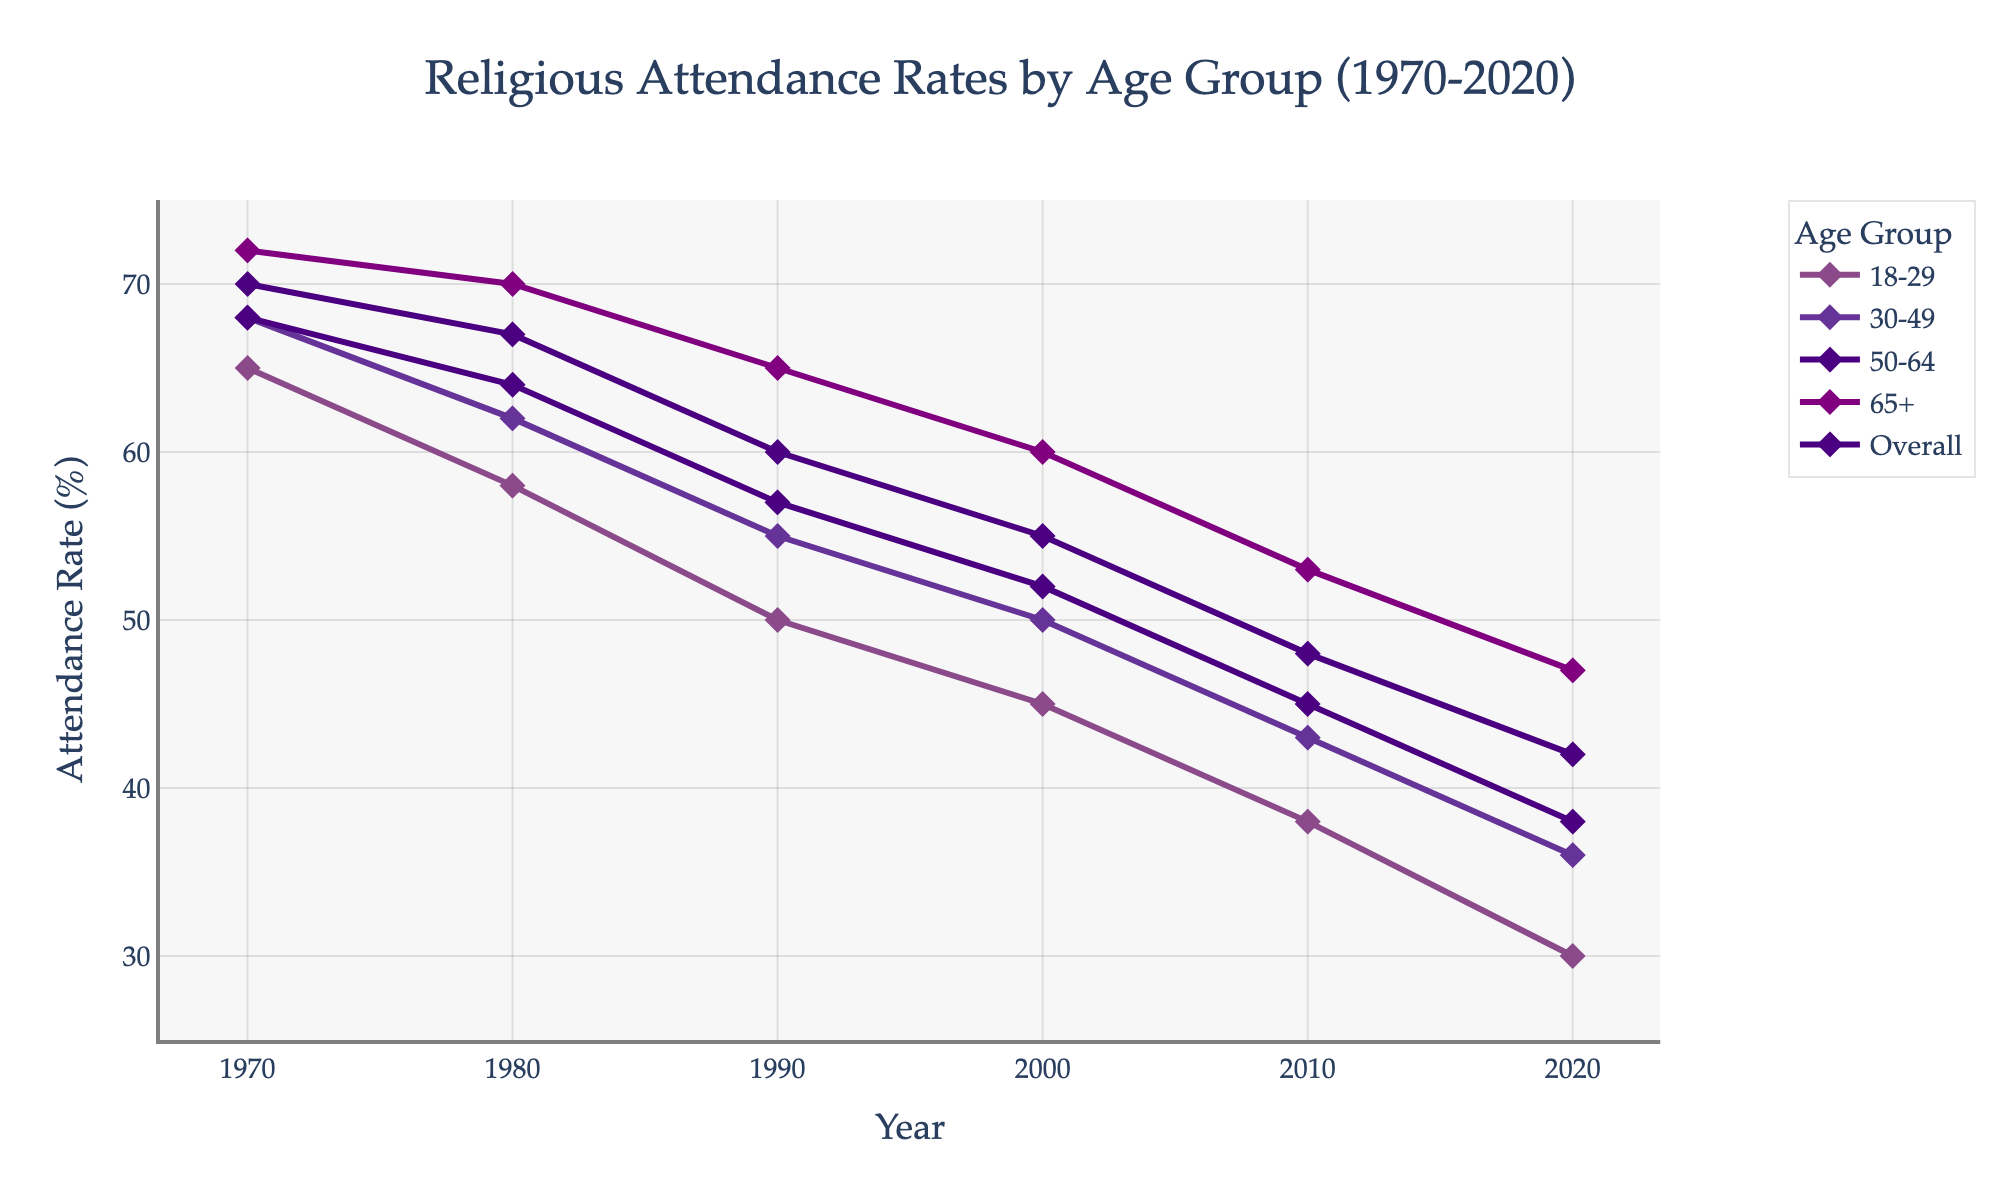What was the attendance rate for the 18-29 age group in 1990? Locate the 18-29 line and find the value at 1990.
Answer: 50 What is the difference in attendance rates between the 65+ age group and the 18-29 age group in 2020? Find the values for both age groups in 2020 and subtract the 18-29 value from the 65+ value (47 - 30).
Answer: 17 Which age group shows the largest decline in attendance rate from 1970 to 2020? Calculate the decline for each age group from 1970 to 2020 and compare.
Answer: 18-29 What is the average attendance rate for the 30-49 age group across the entire period? Sum the attendance rates for the 30-49 age group for all years and divide by the number of years ((68+62+55+50+43+36) / 6).
Answer: 52.3 In which decade does the overall attendance rate drop the most? Calculate the difference for each decade (1970-1980, 1980-1990, etc.) and identify the decade with the largest drop.
Answer: 1980-1990 Which age group had the highest attendance rate in 1980? Locate the highest value among the age group lines for 1980.
Answer: 65+ What is the difference in the rate of decline between the 50-64 and 30-49 age groups from 1970 to 2020? Calculate the decline for each age group and subtract the decline of 30-49 from 50-64 ((70-42) - (68-36)).
Answer: 2 Does any age group maintain a steady trend without large fluctuations? Visually inspect the lines for large fluctuations and identify any group with a relatively steady trend.
Answer: No How does the attendance rate of the 65+ age group in 2020 compare to the overall rate in 1970? Compare the 65+ rate in 2020 with the overall rate in 1970 (47 vs 68).
Answer: Lower By how much did the attendance rate for the 18-29 age group decrease from 2000 to 2010? Subtract the value in 2010 from the value in 2000 (45 - 38).
Answer: 7 